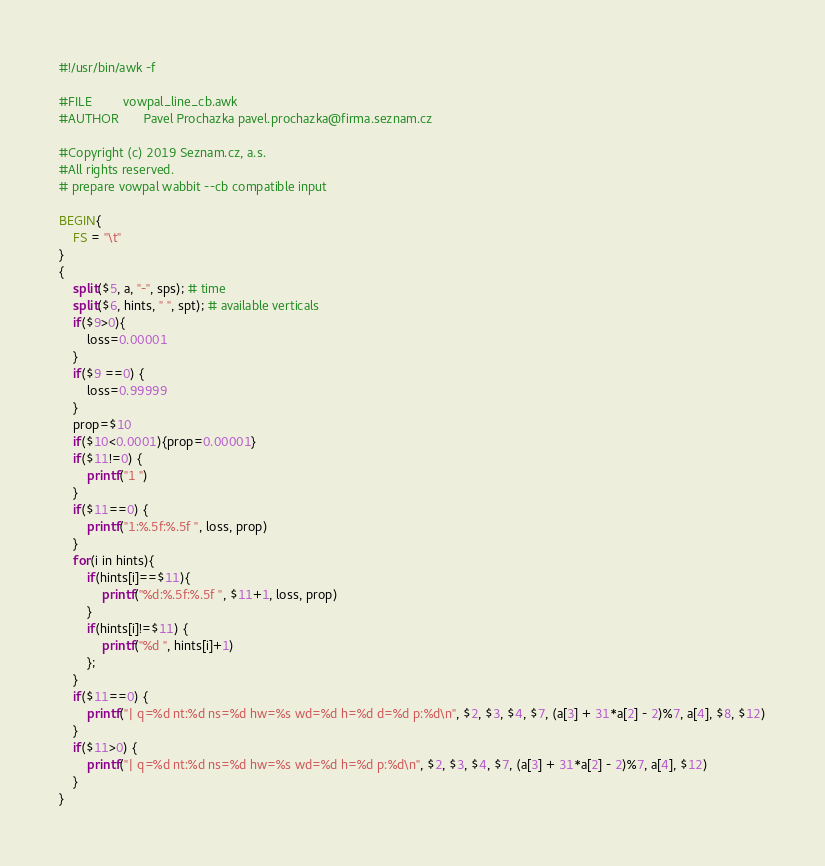Convert code to text. <code><loc_0><loc_0><loc_500><loc_500><_Awk_>#!/usr/bin/awk -f

#FILE         vowpal_line_cb.awk
#AUTHOR       Pavel Prochazka pavel.prochazka@firma.seznam.cz

#Copyright (c) 2019 Seznam.cz, a.s.
#All rights reserved.
# prepare vowpal wabbit --cb compatible input

BEGIN{
    FS = "\t"
}
{
    split($5, a, "-", sps); # time
    split($6, hints, " ", spt); # available verticals
    if($9>0){
        loss=0.00001
    }
    if($9 ==0) {
        loss=0.99999
    }
    prop=$10
    if($10<0.0001){prop=0.00001}
    if($11!=0) {
        printf("1 ")
    }
    if($11==0) {
        printf("1:%.5f:%.5f ", loss, prop)
    }
    for(i in hints){
        if(hints[i]==$11){
            printf("%d:%.5f:%.5f ", $11+1, loss, prop)
        }
        if(hints[i]!=$11) {
            printf("%d ", hints[i]+1)
        };
    }
    if($11==0) {
        printf("| q=%d nt:%d ns=%d hw=%s wd=%d h=%d d=%d p:%d\n", $2, $3, $4, $7, (a[3] + 31*a[2] - 2)%7, a[4], $8, $12)
    }
    if($11>0) {
        printf("| q=%d nt:%d ns=%d hw=%s wd=%d h=%d p:%d\n", $2, $3, $4, $7, (a[3] + 31*a[2] - 2)%7, a[4], $12)
    }
}
</code> 